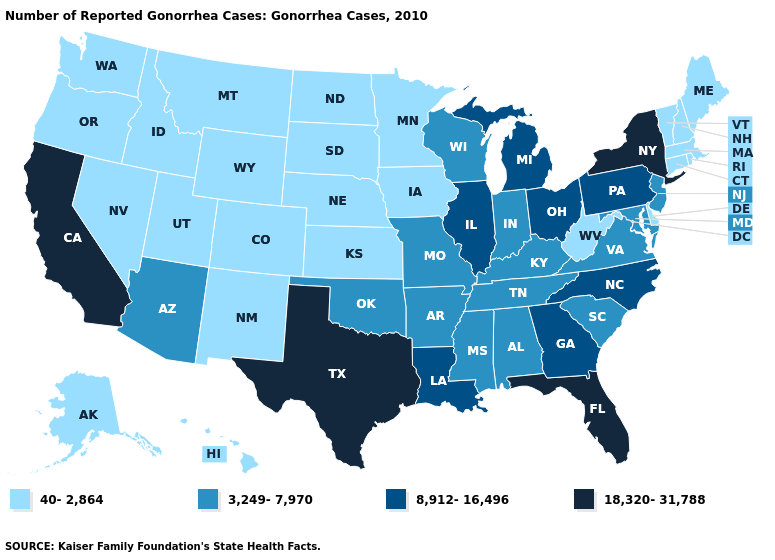What is the value of New York?
Quick response, please. 18,320-31,788. Name the states that have a value in the range 40-2,864?
Quick response, please. Alaska, Colorado, Connecticut, Delaware, Hawaii, Idaho, Iowa, Kansas, Maine, Massachusetts, Minnesota, Montana, Nebraska, Nevada, New Hampshire, New Mexico, North Dakota, Oregon, Rhode Island, South Dakota, Utah, Vermont, Washington, West Virginia, Wyoming. What is the lowest value in the South?
Concise answer only. 40-2,864. Which states have the lowest value in the South?
Give a very brief answer. Delaware, West Virginia. Among the states that border Virginia , which have the lowest value?
Keep it brief. West Virginia. Name the states that have a value in the range 3,249-7,970?
Write a very short answer. Alabama, Arizona, Arkansas, Indiana, Kentucky, Maryland, Mississippi, Missouri, New Jersey, Oklahoma, South Carolina, Tennessee, Virginia, Wisconsin. Name the states that have a value in the range 8,912-16,496?
Answer briefly. Georgia, Illinois, Louisiana, Michigan, North Carolina, Ohio, Pennsylvania. Name the states that have a value in the range 3,249-7,970?
Be succinct. Alabama, Arizona, Arkansas, Indiana, Kentucky, Maryland, Mississippi, Missouri, New Jersey, Oklahoma, South Carolina, Tennessee, Virginia, Wisconsin. Name the states that have a value in the range 8,912-16,496?
Concise answer only. Georgia, Illinois, Louisiana, Michigan, North Carolina, Ohio, Pennsylvania. Name the states that have a value in the range 8,912-16,496?
Concise answer only. Georgia, Illinois, Louisiana, Michigan, North Carolina, Ohio, Pennsylvania. Name the states that have a value in the range 8,912-16,496?
Concise answer only. Georgia, Illinois, Louisiana, Michigan, North Carolina, Ohio, Pennsylvania. Does New York have the highest value in the Northeast?
Write a very short answer. Yes. How many symbols are there in the legend?
Give a very brief answer. 4. Among the states that border Mississippi , does Tennessee have the highest value?
Write a very short answer. No. Name the states that have a value in the range 3,249-7,970?
Concise answer only. Alabama, Arizona, Arkansas, Indiana, Kentucky, Maryland, Mississippi, Missouri, New Jersey, Oklahoma, South Carolina, Tennessee, Virginia, Wisconsin. 